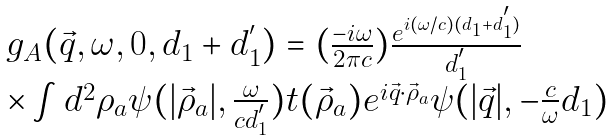<formula> <loc_0><loc_0><loc_500><loc_500>\begin{array} { l } g _ { A } ( \vec { q } , \omega , 0 , d _ { 1 } + d ^ { ^ { \prime } } _ { 1 } ) = ( \frac { - i \omega } { 2 \pi c } ) \frac { e ^ { i ( \omega / c ) ( d _ { 1 } + d ^ { ^ { \prime } } _ { 1 } ) } } { d ^ { ^ { \prime } } _ { 1 } } \\ \times \int d ^ { 2 } \rho _ { a } \psi ( | \vec { \rho } _ { a } | , \frac { \omega } { c d ^ { ^ { \prime } } _ { 1 } } ) t ( \vec { \rho } _ { a } ) e ^ { i \vec { q } \cdot \vec { \rho } _ { a } } \psi ( | \vec { q } | , - \frac { c } { \omega } d _ { 1 } ) \end{array}</formula> 